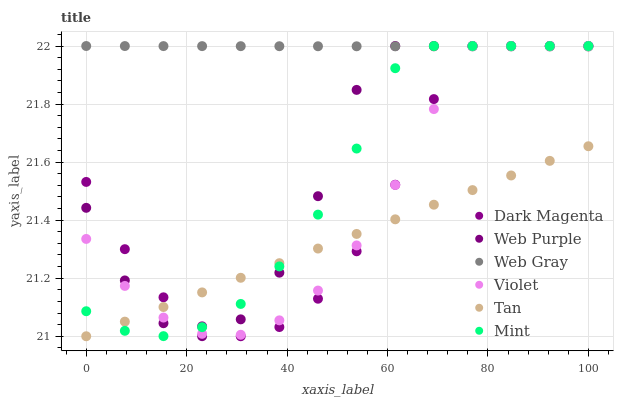Does Tan have the minimum area under the curve?
Answer yes or no. Yes. Does Web Gray have the maximum area under the curve?
Answer yes or no. Yes. Does Dark Magenta have the minimum area under the curve?
Answer yes or no. No. Does Dark Magenta have the maximum area under the curve?
Answer yes or no. No. Is Tan the smoothest?
Answer yes or no. Yes. Is Web Purple the roughest?
Answer yes or no. Yes. Is Dark Magenta the smoothest?
Answer yes or no. No. Is Dark Magenta the roughest?
Answer yes or no. No. Does Tan have the lowest value?
Answer yes or no. Yes. Does Dark Magenta have the lowest value?
Answer yes or no. No. Does Mint have the highest value?
Answer yes or no. Yes. Does Tan have the highest value?
Answer yes or no. No. Is Tan less than Web Gray?
Answer yes or no. Yes. Is Web Gray greater than Tan?
Answer yes or no. Yes. Does Dark Magenta intersect Web Purple?
Answer yes or no. Yes. Is Dark Magenta less than Web Purple?
Answer yes or no. No. Is Dark Magenta greater than Web Purple?
Answer yes or no. No. Does Tan intersect Web Gray?
Answer yes or no. No. 